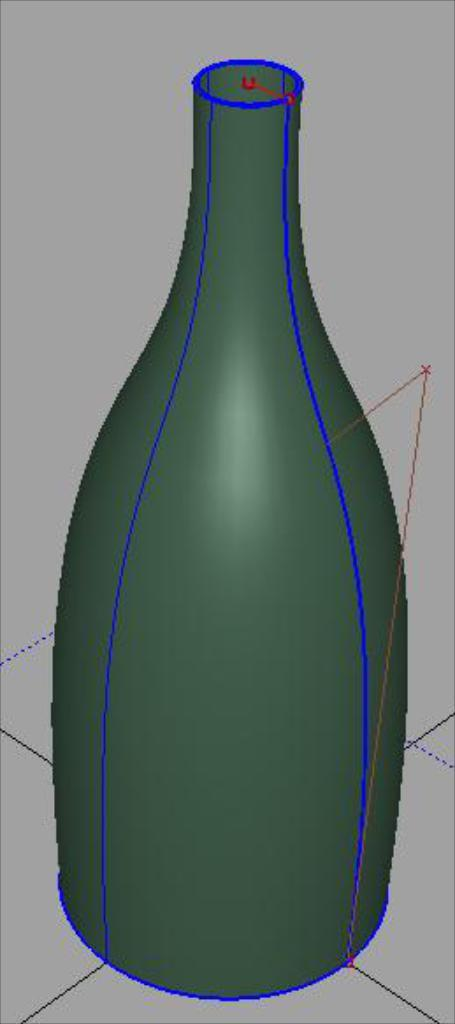What is the main subject of the picture? The main subject of the picture is an animated image of a bottle. What color is the bottle in the image? The bottle is green in color. Are there any additional colors present in the image? Yes, the bottle has blue color border lines. How many train tracks can be seen in the image? There are no train tracks present in the image; it features an animated image of a green bottle with blue border lines. What type of eyes does the bottle have in the image? The image is an animation of a bottle, and bottles do not have eyes. 